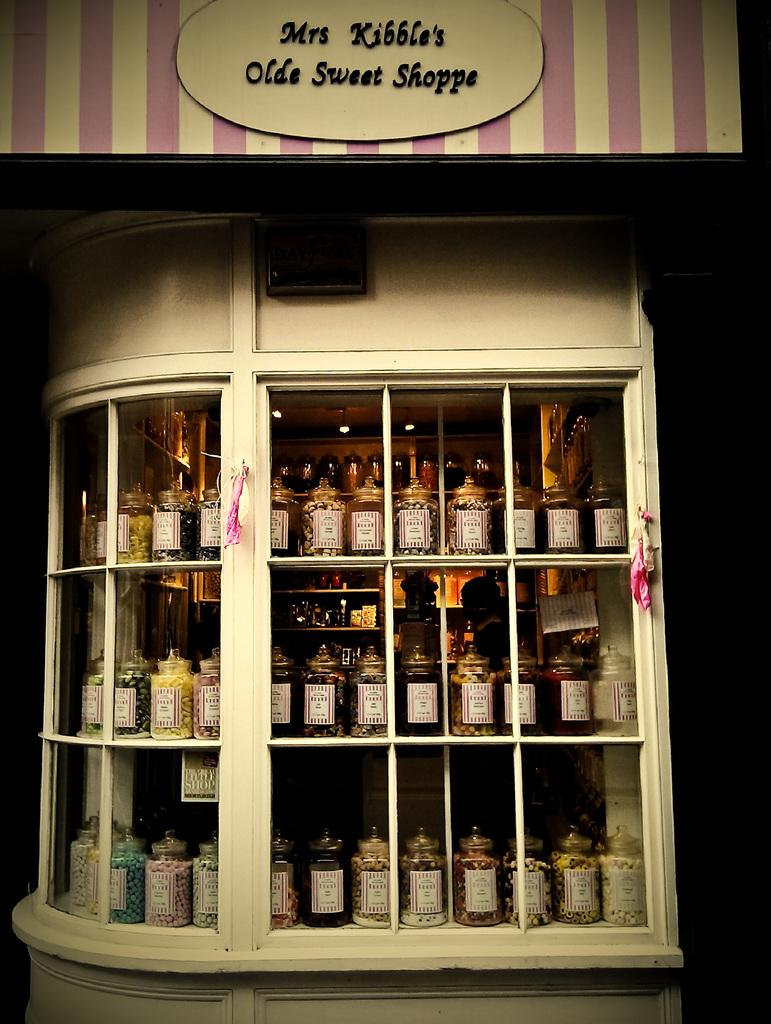<image>
Write a terse but informative summary of the picture. Several jars of candies sit in the window on Mrs Kibble's Olde Sweet Shoppe. 